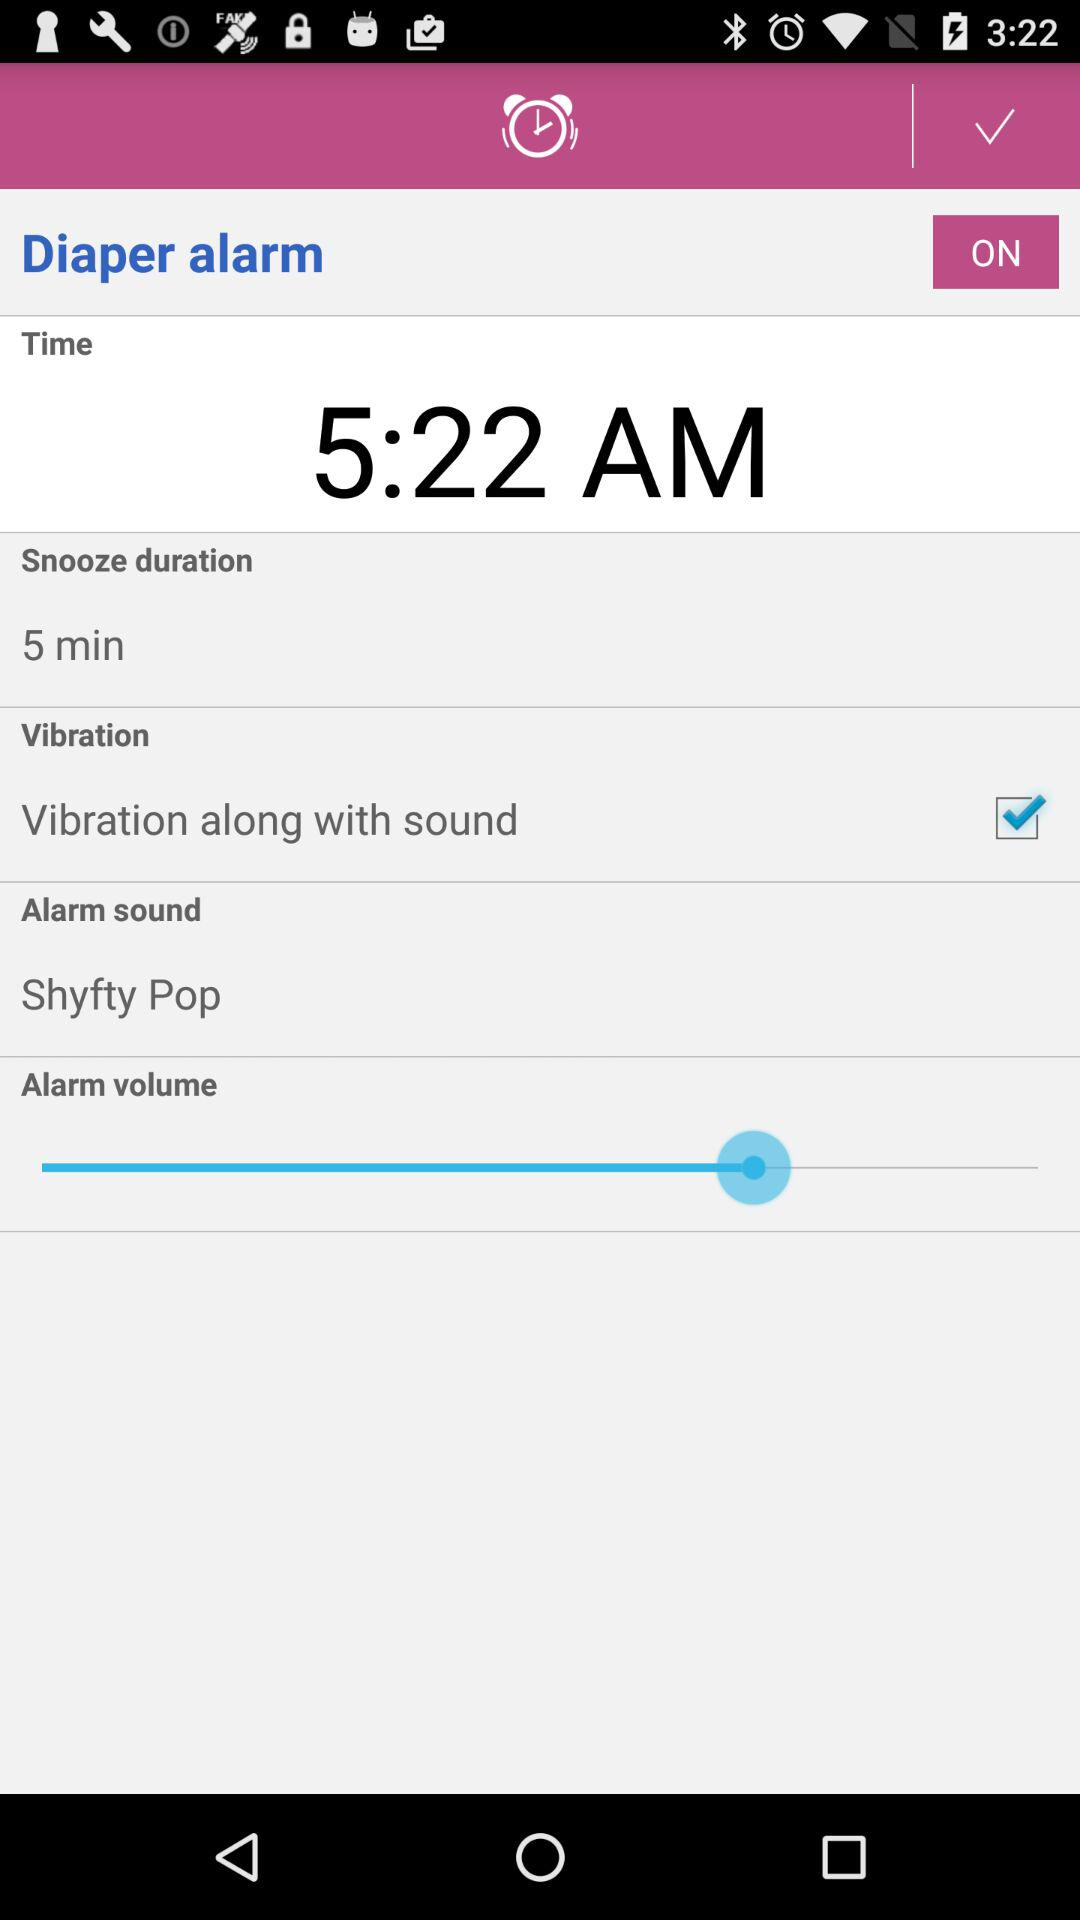What is the status of "Diaper alarm"? The status is "on". 